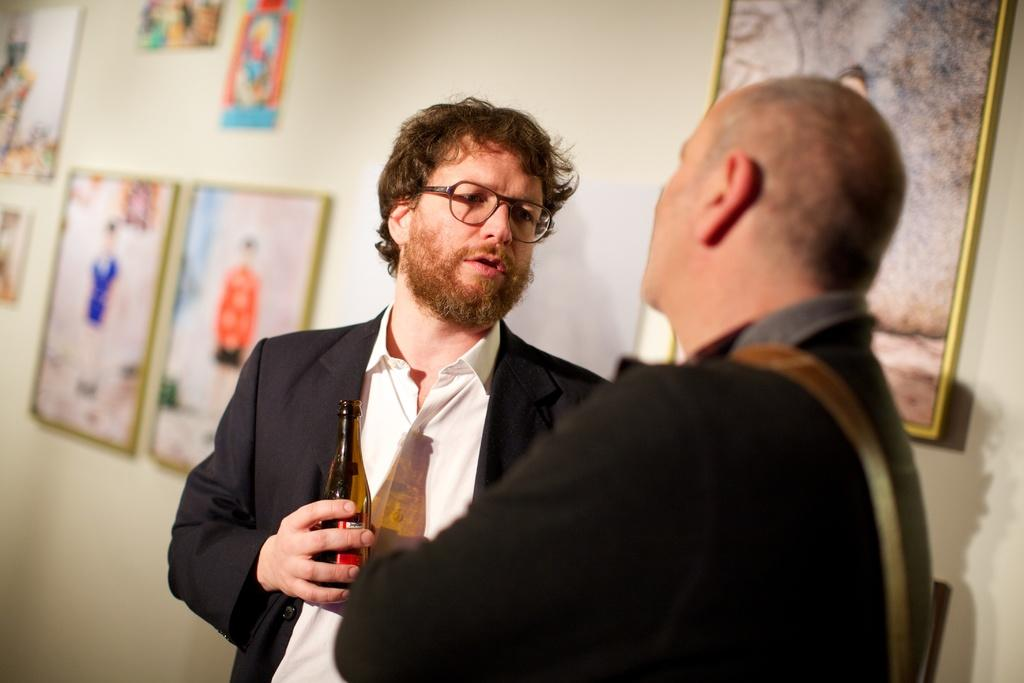How many people are present in the image? There are two persons standing in the image. Can you describe the background of the image? There is a frame attached to a wall in the background of the image. What type of seed can be seen growing near the frame in the image? There is no seed present in the image; the background only features a frame attached to a wall. 